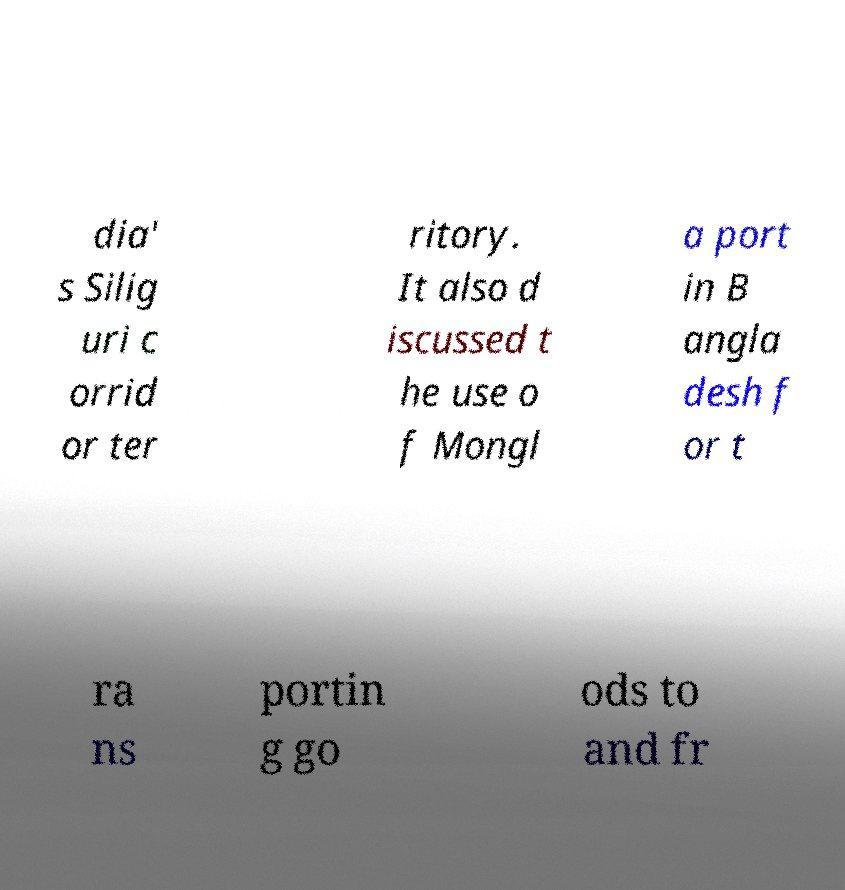Can you read and provide the text displayed in the image?This photo seems to have some interesting text. Can you extract and type it out for me? dia' s Silig uri c orrid or ter ritory. It also d iscussed t he use o f Mongl a port in B angla desh f or t ra ns portin g go ods to and fr 